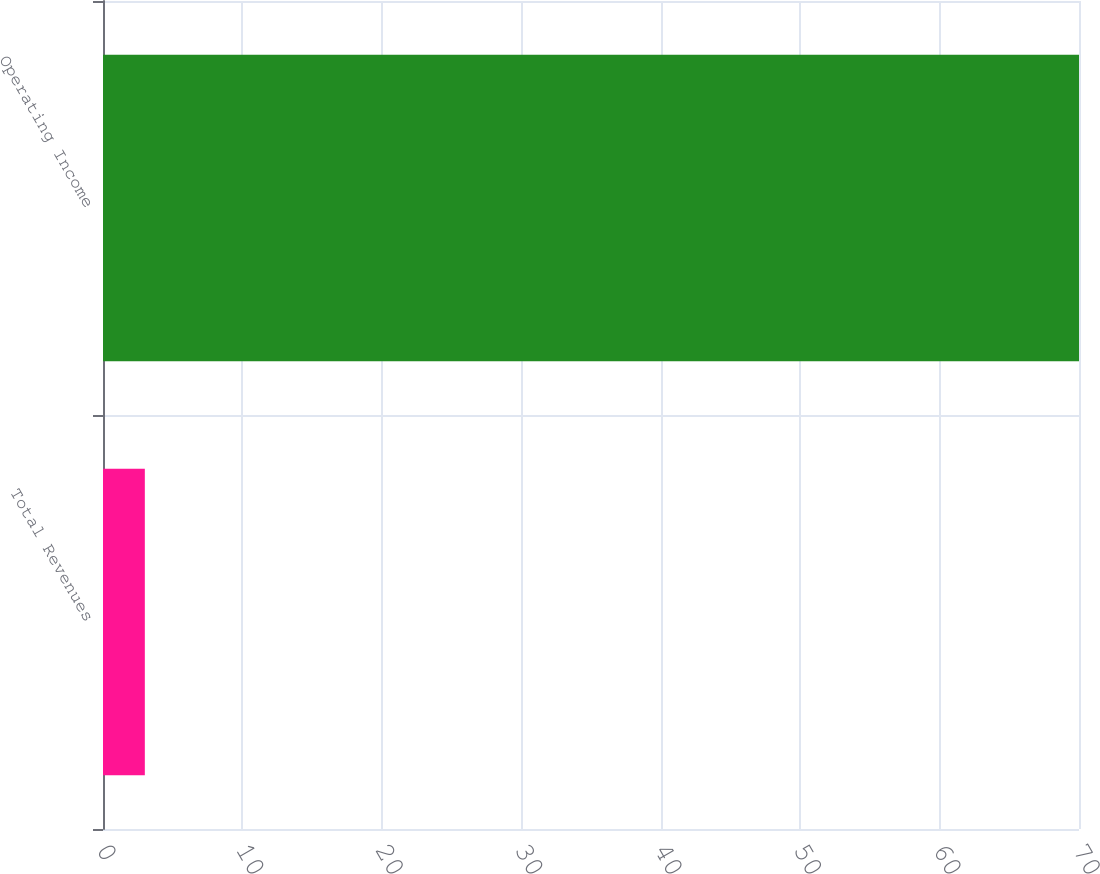Convert chart to OTSL. <chart><loc_0><loc_0><loc_500><loc_500><bar_chart><fcel>Total Revenues<fcel>Operating Income<nl><fcel>3<fcel>70<nl></chart> 